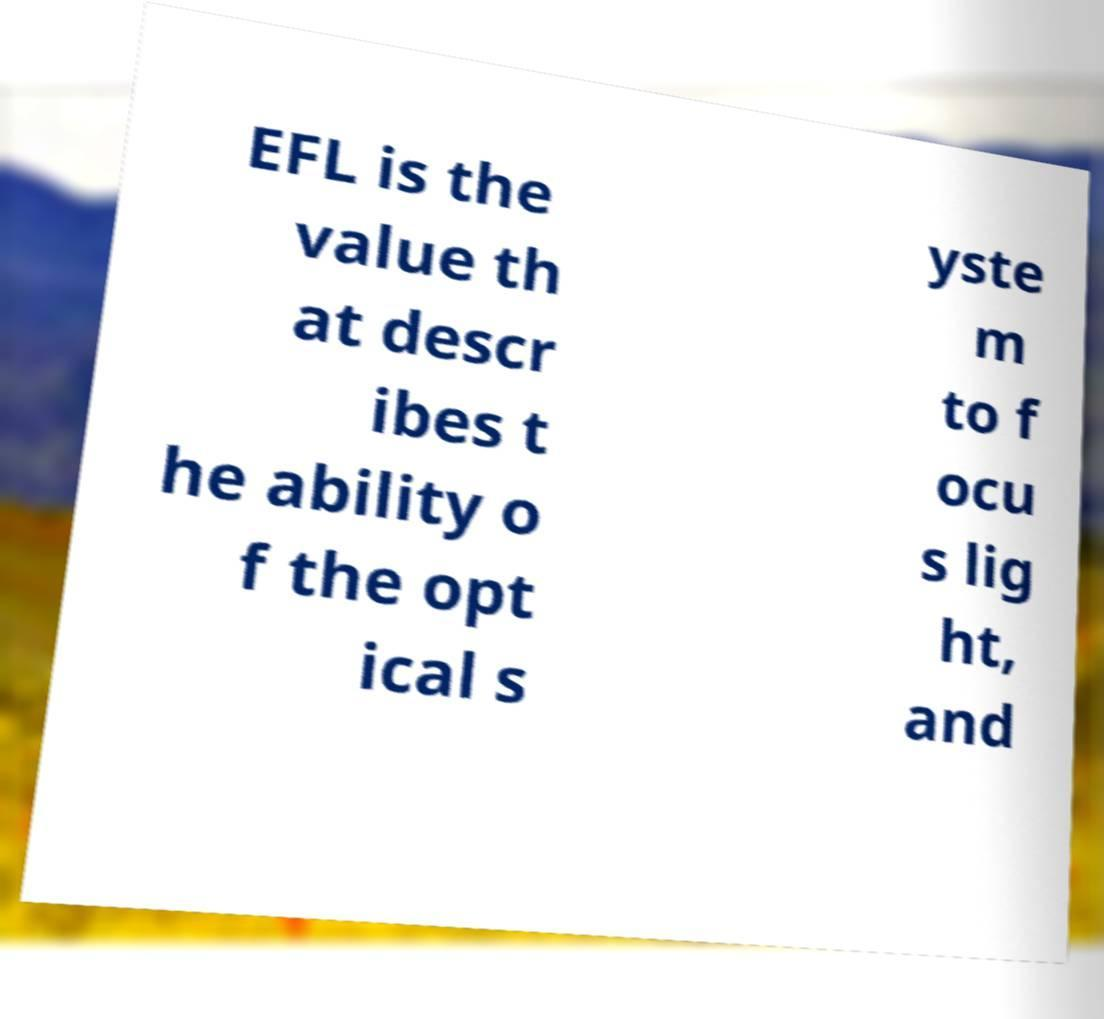Please read and relay the text visible in this image. What does it say? EFL is the value th at descr ibes t he ability o f the opt ical s yste m to f ocu s lig ht, and 